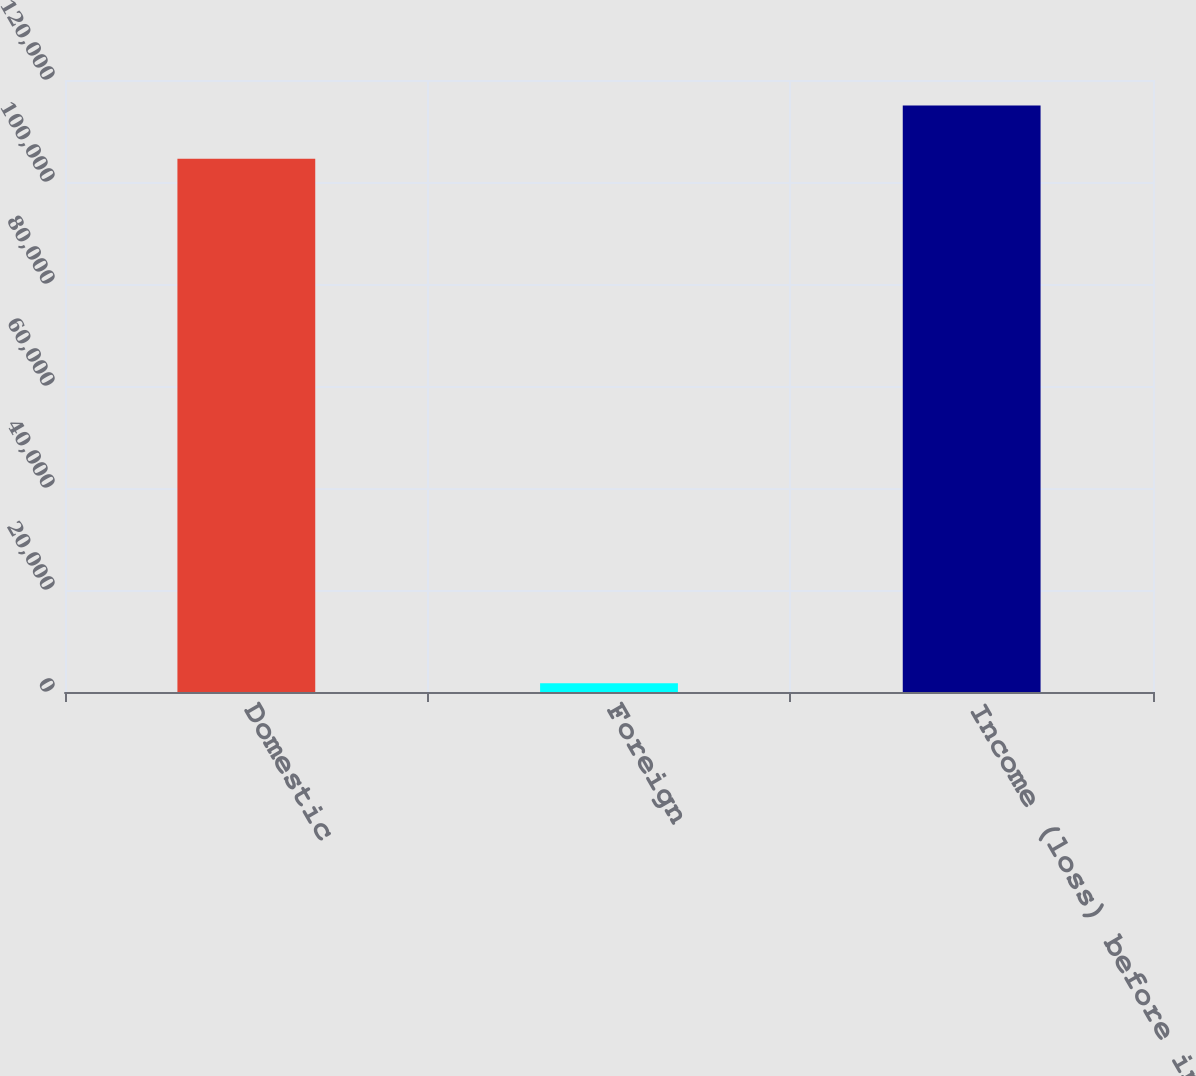Convert chart. <chart><loc_0><loc_0><loc_500><loc_500><bar_chart><fcel>Domestic<fcel>Foreign<fcel>Income (loss) before income<nl><fcel>104556<fcel>1706<fcel>115012<nl></chart> 